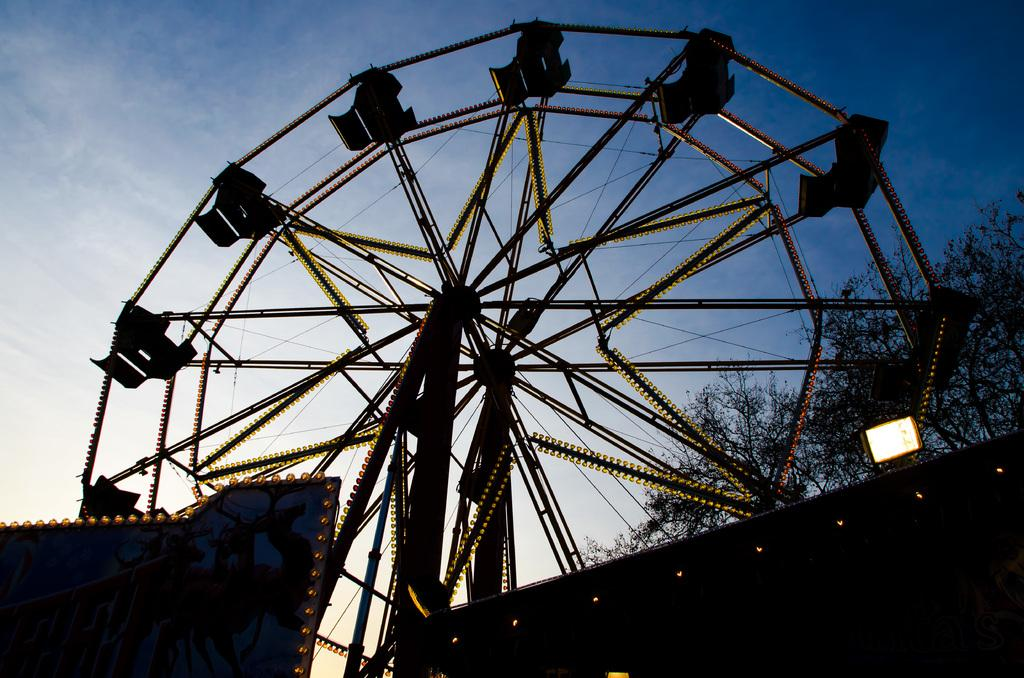What is the main feature in the image? There is a giant wheel in the image. Can you describe the background of the image? There is a tree behind the giant wheel. What type of bun is being used to tell a story in the image? There is no bun or storytelling activity present in the image. 